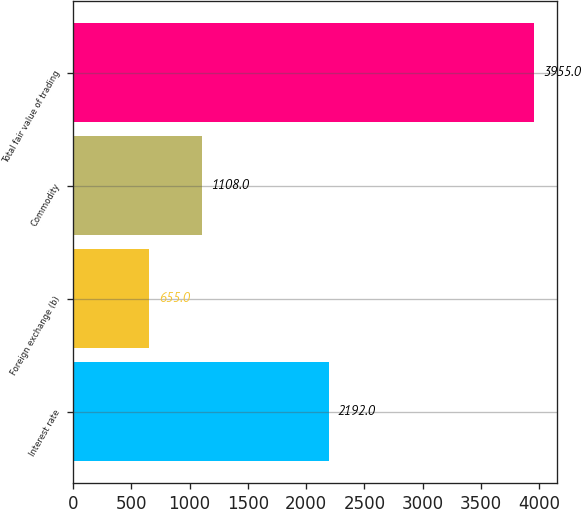<chart> <loc_0><loc_0><loc_500><loc_500><bar_chart><fcel>Interest rate<fcel>Foreign exchange (b)<fcel>Commodity<fcel>Total fair value of trading<nl><fcel>2192<fcel>655<fcel>1108<fcel>3955<nl></chart> 